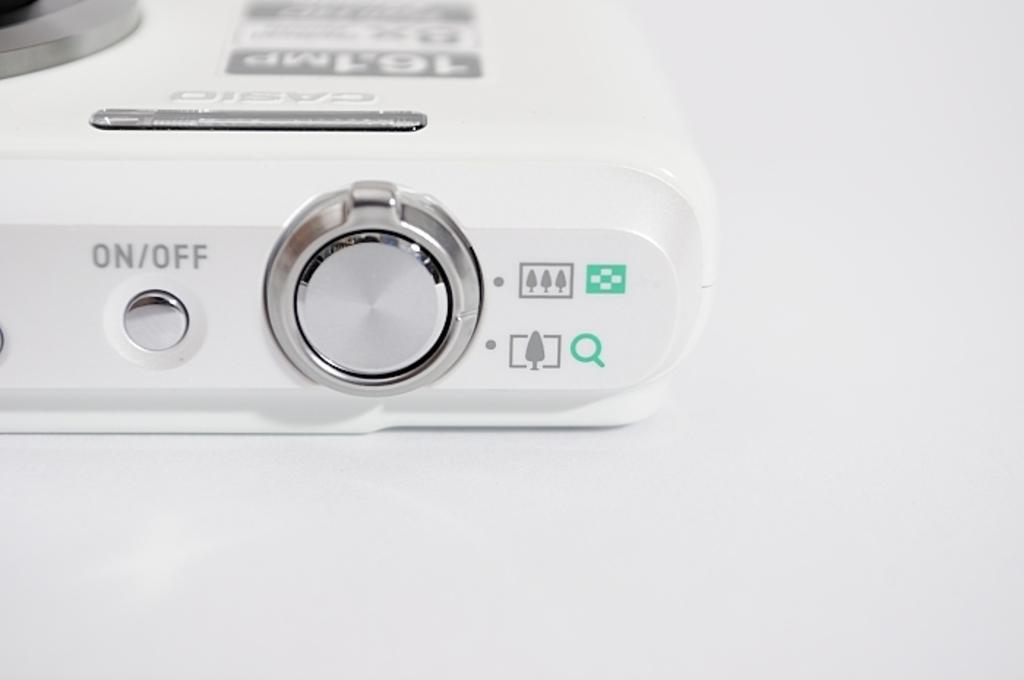<image>
Give a short and clear explanation of the subsequent image. controls of an over exposed Casio piece of equipment 